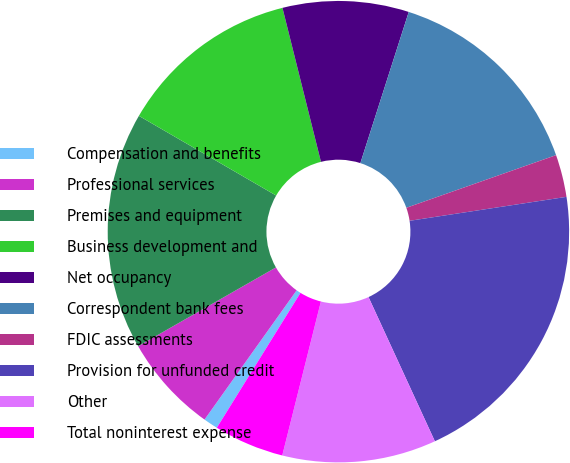<chart> <loc_0><loc_0><loc_500><loc_500><pie_chart><fcel>Compensation and benefits<fcel>Professional services<fcel>Premises and equipment<fcel>Business development and<fcel>Net occupancy<fcel>Correspondent bank fees<fcel>FDIC assessments<fcel>Provision for unfunded credit<fcel>Other<fcel>Total noninterest expense<nl><fcel>1.02%<fcel>6.88%<fcel>16.64%<fcel>12.73%<fcel>8.83%<fcel>14.69%<fcel>2.97%<fcel>20.55%<fcel>10.78%<fcel>4.92%<nl></chart> 